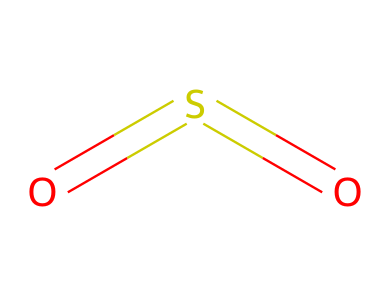What is the chemical name represented by this structure? The structure shows two oxygen atoms double-bonded to a sulfur atom, which is recognized as sulfur dioxide.
Answer: sulfur dioxide How many atoms are present in this molecule? The molecule consists of one sulfur atom and two oxygen atoms, totaling three atoms.
Answer: three What type of bonding is present in this compound? The sulfur atom is double-bonded to each oxygen atom, indicating that there are double bonds in this compound.
Answer: double bonds What is the total number of bonds in this chemical structure? There are two double bonds present (one for each sulfur-oxygen connection), making a total of four bonds (each double bond has two bonds).
Answer: four How does this compound contribute to acid rain? Sulfur dioxide can react with water in the atmosphere to form sulfurous acid, which contributes to the acidity of rain.
Answer: sulfurous acid What is a common source of this chemical in the environment? Sulfur dioxide is often released into the atmosphere from the burning of fossil fuels in power plants and vehicles.
Answer: fossil fuels 